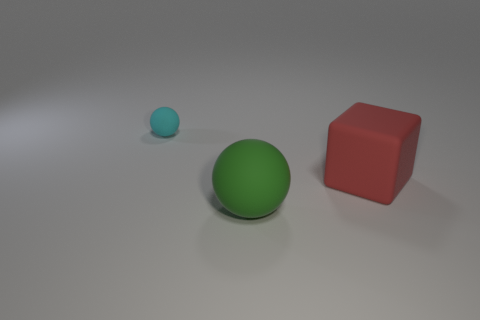Is there any other thing that is the same size as the cyan matte thing?
Your response must be concise. No. Are any purple metallic things visible?
Make the answer very short. No. How big is the object that is on the right side of the ball that is in front of the ball left of the large green sphere?
Your answer should be compact. Large. What number of tiny brown balls are made of the same material as the red thing?
Your response must be concise. 0. What number of other matte things have the same size as the green rubber object?
Your answer should be compact. 1. There is a object that is behind the matte object right of the large thing left of the red thing; what is its material?
Offer a terse response. Rubber. How many things are big purple cylinders or large matte spheres?
Give a very brief answer. 1. The large red thing has what shape?
Make the answer very short. Cube. What shape is the thing that is on the left side of the big rubber object that is to the left of the red object?
Give a very brief answer. Sphere. Does the ball in front of the red block have the same material as the cyan sphere?
Offer a terse response. Yes. 